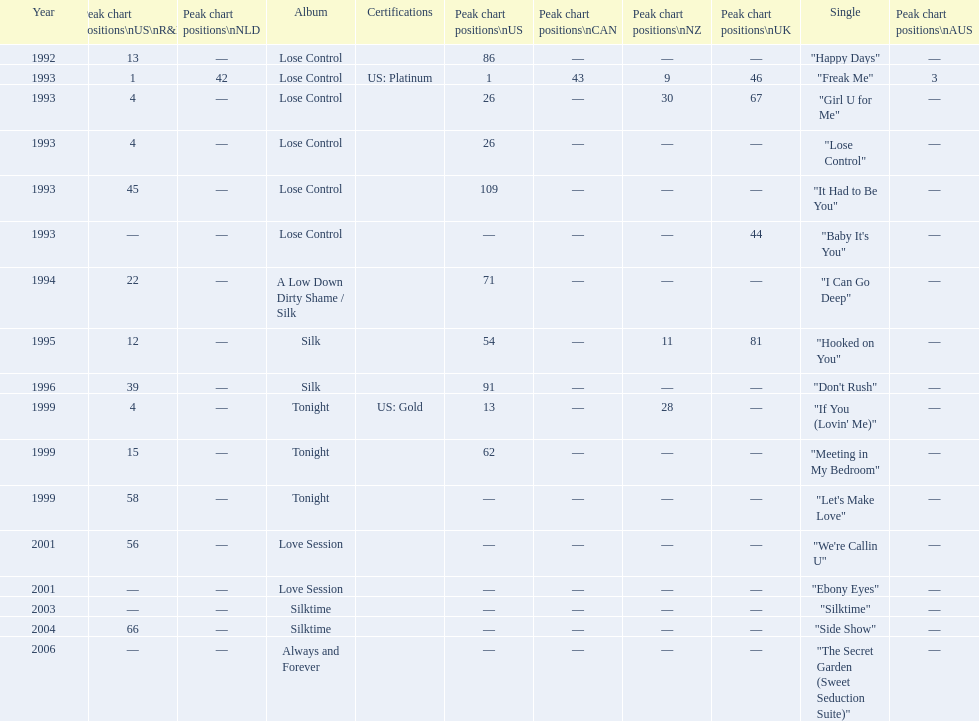Which single is the most in terms of how many times it charted? "Freak Me". 